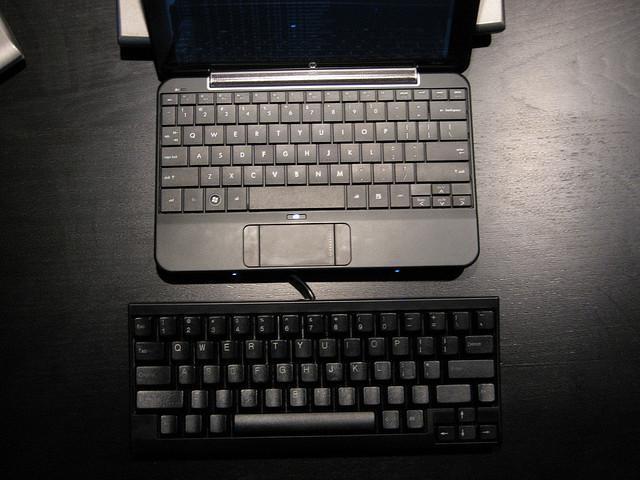How many keyboards are there?
Give a very brief answer. 2. 